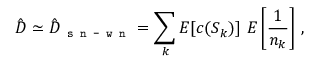Convert formula to latex. <formula><loc_0><loc_0><loc_500><loc_500>\hat { D } \simeq \hat { D } _ { s n - w n } = \sum _ { k } E [ c ( S _ { k } ) ] \ E \left [ \frac { 1 } { n _ { k } } \right ] \, ,</formula> 